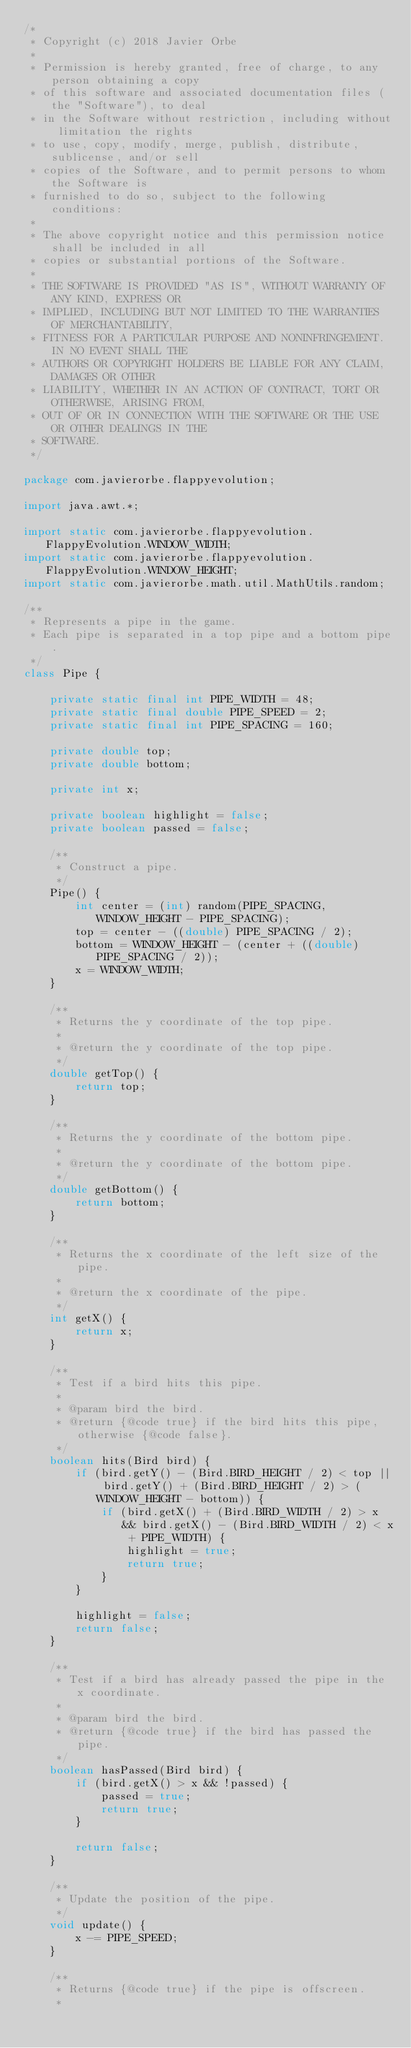Convert code to text. <code><loc_0><loc_0><loc_500><loc_500><_Java_>/*
 * Copyright (c) 2018 Javier Orbe
 *
 * Permission is hereby granted, free of charge, to any person obtaining a copy
 * of this software and associated documentation files (the "Software"), to deal
 * in the Software without restriction, including without limitation the rights
 * to use, copy, modify, merge, publish, distribute, sublicense, and/or sell
 * copies of the Software, and to permit persons to whom the Software is
 * furnished to do so, subject to the following conditions:
 *
 * The above copyright notice and this permission notice shall be included in all
 * copies or substantial portions of the Software.
 *
 * THE SOFTWARE IS PROVIDED "AS IS", WITHOUT WARRANTY OF ANY KIND, EXPRESS OR
 * IMPLIED, INCLUDING BUT NOT LIMITED TO THE WARRANTIES OF MERCHANTABILITY,
 * FITNESS FOR A PARTICULAR PURPOSE AND NONINFRINGEMENT. IN NO EVENT SHALL THE
 * AUTHORS OR COPYRIGHT HOLDERS BE LIABLE FOR ANY CLAIM, DAMAGES OR OTHER
 * LIABILITY, WHETHER IN AN ACTION OF CONTRACT, TORT OR OTHERWISE, ARISING FROM,
 * OUT OF OR IN CONNECTION WITH THE SOFTWARE OR THE USE OR OTHER DEALINGS IN THE
 * SOFTWARE.
 */

package com.javierorbe.flappyevolution;

import java.awt.*;

import static com.javierorbe.flappyevolution.FlappyEvolution.WINDOW_WIDTH;
import static com.javierorbe.flappyevolution.FlappyEvolution.WINDOW_HEIGHT;
import static com.javierorbe.math.util.MathUtils.random;

/**
 * Represents a pipe in the game.
 * Each pipe is separated in a top pipe and a bottom pipe.
 */
class Pipe {

    private static final int PIPE_WIDTH = 48;
    private static final double PIPE_SPEED = 2;
    private static final int PIPE_SPACING = 160;

    private double top;
    private double bottom;

    private int x;

    private boolean highlight = false;
    private boolean passed = false;

    /**
     * Construct a pipe.
     */
    Pipe() {
        int center = (int) random(PIPE_SPACING, WINDOW_HEIGHT - PIPE_SPACING);
        top = center - ((double) PIPE_SPACING / 2);
        bottom = WINDOW_HEIGHT - (center + ((double) PIPE_SPACING / 2));
        x = WINDOW_WIDTH;
    }

    /**
     * Returns the y coordinate of the top pipe.
     *
     * @return the y coordinate of the top pipe.
     */
    double getTop() {
        return top;
    }

    /**
     * Returns the y coordinate of the bottom pipe.
     *
     * @return the y coordinate of the bottom pipe.
     */
    double getBottom() {
        return bottom;
    }

    /**
     * Returns the x coordinate of the left size of the pipe.
     *
     * @return the x coordinate of the pipe.
     */
    int getX() {
        return x;
    }

    /**
     * Test if a bird hits this pipe.
     *
     * @param bird the bird.
     * @return {@code true} if the bird hits this pipe, otherwise {@code false}.
     */
    boolean hits(Bird bird) {
        if (bird.getY() - (Bird.BIRD_HEIGHT / 2) < top || bird.getY() + (Bird.BIRD_HEIGHT / 2) > (WINDOW_HEIGHT - bottom)) {
            if (bird.getX() + (Bird.BIRD_WIDTH / 2) > x && bird.getX() - (Bird.BIRD_WIDTH / 2) < x + PIPE_WIDTH) {
                highlight = true;
                return true;
            }
        }

        highlight = false;
        return false;
    }

    /**
     * Test if a bird has already passed the pipe in the x coordinate.
     *
     * @param bird the bird.
     * @return {@code true} if the bird has passed the pipe.
     */
    boolean hasPassed(Bird bird) {
        if (bird.getX() > x && !passed) {
            passed = true;
            return true;
        }

        return false;
    }

    /**
     * Update the position of the pipe.
     */
    void update() {
        x -= PIPE_SPEED;
    }

    /**
     * Returns {@code true} if the pipe is offscreen.
     *</code> 